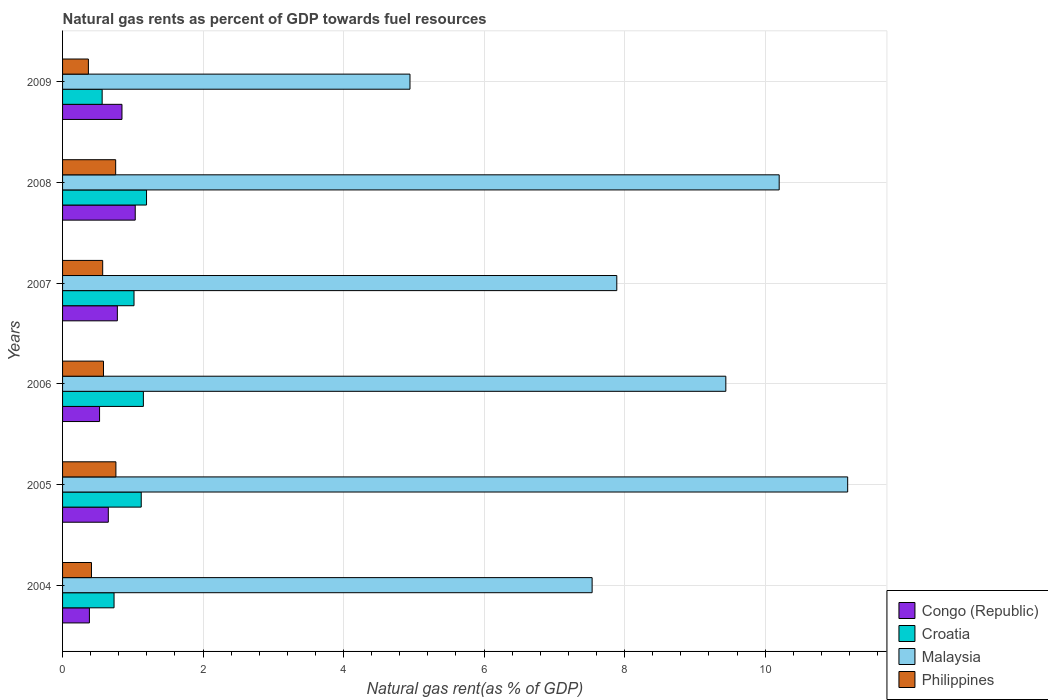How many different coloured bars are there?
Ensure brevity in your answer.  4. What is the label of the 6th group of bars from the top?
Ensure brevity in your answer.  2004. What is the natural gas rent in Croatia in 2009?
Offer a terse response. 0.56. Across all years, what is the maximum natural gas rent in Philippines?
Make the answer very short. 0.76. Across all years, what is the minimum natural gas rent in Philippines?
Your response must be concise. 0.37. In which year was the natural gas rent in Malaysia maximum?
Your answer should be compact. 2005. What is the total natural gas rent in Philippines in the graph?
Your answer should be compact. 3.45. What is the difference between the natural gas rent in Croatia in 2004 and that in 2009?
Your answer should be compact. 0.17. What is the difference between the natural gas rent in Philippines in 2005 and the natural gas rent in Congo (Republic) in 2008?
Ensure brevity in your answer.  -0.28. What is the average natural gas rent in Malaysia per year?
Your response must be concise. 8.53. In the year 2007, what is the difference between the natural gas rent in Malaysia and natural gas rent in Philippines?
Make the answer very short. 7.32. In how many years, is the natural gas rent in Philippines greater than 2.4 %?
Make the answer very short. 0. What is the ratio of the natural gas rent in Malaysia in 2005 to that in 2008?
Provide a short and direct response. 1.1. Is the difference between the natural gas rent in Malaysia in 2004 and 2008 greater than the difference between the natural gas rent in Philippines in 2004 and 2008?
Your response must be concise. No. What is the difference between the highest and the second highest natural gas rent in Malaysia?
Offer a terse response. 0.97. What is the difference between the highest and the lowest natural gas rent in Croatia?
Keep it short and to the point. 0.63. In how many years, is the natural gas rent in Malaysia greater than the average natural gas rent in Malaysia taken over all years?
Your response must be concise. 3. Is the sum of the natural gas rent in Malaysia in 2005 and 2006 greater than the maximum natural gas rent in Philippines across all years?
Make the answer very short. Yes. What does the 2nd bar from the top in 2004 represents?
Provide a succinct answer. Malaysia. What does the 3rd bar from the bottom in 2005 represents?
Offer a very short reply. Malaysia. How many years are there in the graph?
Provide a short and direct response. 6. Are the values on the major ticks of X-axis written in scientific E-notation?
Make the answer very short. No. Does the graph contain any zero values?
Provide a short and direct response. No. What is the title of the graph?
Make the answer very short. Natural gas rents as percent of GDP towards fuel resources. Does "Eritrea" appear as one of the legend labels in the graph?
Provide a succinct answer. No. What is the label or title of the X-axis?
Provide a succinct answer. Natural gas rent(as % of GDP). What is the Natural gas rent(as % of GDP) of Congo (Republic) in 2004?
Ensure brevity in your answer.  0.38. What is the Natural gas rent(as % of GDP) of Croatia in 2004?
Your answer should be compact. 0.73. What is the Natural gas rent(as % of GDP) of Malaysia in 2004?
Your response must be concise. 7.54. What is the Natural gas rent(as % of GDP) of Philippines in 2004?
Keep it short and to the point. 0.41. What is the Natural gas rent(as % of GDP) of Congo (Republic) in 2005?
Your response must be concise. 0.65. What is the Natural gas rent(as % of GDP) of Croatia in 2005?
Provide a succinct answer. 1.12. What is the Natural gas rent(as % of GDP) in Malaysia in 2005?
Provide a succinct answer. 11.18. What is the Natural gas rent(as % of GDP) in Philippines in 2005?
Make the answer very short. 0.76. What is the Natural gas rent(as % of GDP) of Congo (Republic) in 2006?
Offer a very short reply. 0.53. What is the Natural gas rent(as % of GDP) in Croatia in 2006?
Your answer should be very brief. 1.15. What is the Natural gas rent(as % of GDP) of Malaysia in 2006?
Make the answer very short. 9.44. What is the Natural gas rent(as % of GDP) of Philippines in 2006?
Provide a succinct answer. 0.58. What is the Natural gas rent(as % of GDP) of Congo (Republic) in 2007?
Give a very brief answer. 0.78. What is the Natural gas rent(as % of GDP) of Croatia in 2007?
Provide a short and direct response. 1.02. What is the Natural gas rent(as % of GDP) of Malaysia in 2007?
Your answer should be very brief. 7.89. What is the Natural gas rent(as % of GDP) of Philippines in 2007?
Make the answer very short. 0.57. What is the Natural gas rent(as % of GDP) in Congo (Republic) in 2008?
Your answer should be very brief. 1.03. What is the Natural gas rent(as % of GDP) in Croatia in 2008?
Keep it short and to the point. 1.2. What is the Natural gas rent(as % of GDP) of Malaysia in 2008?
Give a very brief answer. 10.2. What is the Natural gas rent(as % of GDP) in Philippines in 2008?
Your answer should be very brief. 0.76. What is the Natural gas rent(as % of GDP) in Congo (Republic) in 2009?
Your answer should be very brief. 0.85. What is the Natural gas rent(as % of GDP) in Croatia in 2009?
Ensure brevity in your answer.  0.56. What is the Natural gas rent(as % of GDP) of Malaysia in 2009?
Keep it short and to the point. 4.95. What is the Natural gas rent(as % of GDP) in Philippines in 2009?
Provide a short and direct response. 0.37. Across all years, what is the maximum Natural gas rent(as % of GDP) of Congo (Republic)?
Offer a very short reply. 1.03. Across all years, what is the maximum Natural gas rent(as % of GDP) in Croatia?
Offer a very short reply. 1.2. Across all years, what is the maximum Natural gas rent(as % of GDP) in Malaysia?
Ensure brevity in your answer.  11.18. Across all years, what is the maximum Natural gas rent(as % of GDP) of Philippines?
Offer a terse response. 0.76. Across all years, what is the minimum Natural gas rent(as % of GDP) of Congo (Republic)?
Keep it short and to the point. 0.38. Across all years, what is the minimum Natural gas rent(as % of GDP) of Croatia?
Your answer should be very brief. 0.56. Across all years, what is the minimum Natural gas rent(as % of GDP) in Malaysia?
Offer a very short reply. 4.95. Across all years, what is the minimum Natural gas rent(as % of GDP) of Philippines?
Keep it short and to the point. 0.37. What is the total Natural gas rent(as % of GDP) of Congo (Republic) in the graph?
Offer a terse response. 4.22. What is the total Natural gas rent(as % of GDP) in Croatia in the graph?
Your response must be concise. 5.78. What is the total Natural gas rent(as % of GDP) in Malaysia in the graph?
Make the answer very short. 51.19. What is the total Natural gas rent(as % of GDP) of Philippines in the graph?
Your answer should be very brief. 3.45. What is the difference between the Natural gas rent(as % of GDP) of Congo (Republic) in 2004 and that in 2005?
Offer a very short reply. -0.27. What is the difference between the Natural gas rent(as % of GDP) of Croatia in 2004 and that in 2005?
Ensure brevity in your answer.  -0.39. What is the difference between the Natural gas rent(as % of GDP) of Malaysia in 2004 and that in 2005?
Keep it short and to the point. -3.64. What is the difference between the Natural gas rent(as % of GDP) in Philippines in 2004 and that in 2005?
Provide a short and direct response. -0.35. What is the difference between the Natural gas rent(as % of GDP) in Congo (Republic) in 2004 and that in 2006?
Provide a succinct answer. -0.14. What is the difference between the Natural gas rent(as % of GDP) in Croatia in 2004 and that in 2006?
Your response must be concise. -0.42. What is the difference between the Natural gas rent(as % of GDP) of Malaysia in 2004 and that in 2006?
Provide a succinct answer. -1.9. What is the difference between the Natural gas rent(as % of GDP) of Philippines in 2004 and that in 2006?
Your answer should be very brief. -0.17. What is the difference between the Natural gas rent(as % of GDP) of Congo (Republic) in 2004 and that in 2007?
Keep it short and to the point. -0.4. What is the difference between the Natural gas rent(as % of GDP) in Croatia in 2004 and that in 2007?
Your answer should be compact. -0.28. What is the difference between the Natural gas rent(as % of GDP) of Malaysia in 2004 and that in 2007?
Provide a succinct answer. -0.35. What is the difference between the Natural gas rent(as % of GDP) of Philippines in 2004 and that in 2007?
Provide a short and direct response. -0.16. What is the difference between the Natural gas rent(as % of GDP) in Congo (Republic) in 2004 and that in 2008?
Keep it short and to the point. -0.65. What is the difference between the Natural gas rent(as % of GDP) of Croatia in 2004 and that in 2008?
Keep it short and to the point. -0.46. What is the difference between the Natural gas rent(as % of GDP) in Malaysia in 2004 and that in 2008?
Make the answer very short. -2.66. What is the difference between the Natural gas rent(as % of GDP) of Philippines in 2004 and that in 2008?
Provide a short and direct response. -0.34. What is the difference between the Natural gas rent(as % of GDP) of Congo (Republic) in 2004 and that in 2009?
Your answer should be compact. -0.46. What is the difference between the Natural gas rent(as % of GDP) of Croatia in 2004 and that in 2009?
Give a very brief answer. 0.17. What is the difference between the Natural gas rent(as % of GDP) in Malaysia in 2004 and that in 2009?
Provide a short and direct response. 2.59. What is the difference between the Natural gas rent(as % of GDP) of Philippines in 2004 and that in 2009?
Offer a terse response. 0.04. What is the difference between the Natural gas rent(as % of GDP) in Congo (Republic) in 2005 and that in 2006?
Ensure brevity in your answer.  0.12. What is the difference between the Natural gas rent(as % of GDP) in Croatia in 2005 and that in 2006?
Offer a very short reply. -0.03. What is the difference between the Natural gas rent(as % of GDP) of Malaysia in 2005 and that in 2006?
Offer a very short reply. 1.73. What is the difference between the Natural gas rent(as % of GDP) in Philippines in 2005 and that in 2006?
Make the answer very short. 0.18. What is the difference between the Natural gas rent(as % of GDP) of Congo (Republic) in 2005 and that in 2007?
Give a very brief answer. -0.13. What is the difference between the Natural gas rent(as % of GDP) of Croatia in 2005 and that in 2007?
Keep it short and to the point. 0.1. What is the difference between the Natural gas rent(as % of GDP) in Malaysia in 2005 and that in 2007?
Keep it short and to the point. 3.29. What is the difference between the Natural gas rent(as % of GDP) of Philippines in 2005 and that in 2007?
Make the answer very short. 0.19. What is the difference between the Natural gas rent(as % of GDP) in Congo (Republic) in 2005 and that in 2008?
Give a very brief answer. -0.38. What is the difference between the Natural gas rent(as % of GDP) of Croatia in 2005 and that in 2008?
Your answer should be very brief. -0.08. What is the difference between the Natural gas rent(as % of GDP) of Malaysia in 2005 and that in 2008?
Make the answer very short. 0.97. What is the difference between the Natural gas rent(as % of GDP) of Philippines in 2005 and that in 2008?
Make the answer very short. 0. What is the difference between the Natural gas rent(as % of GDP) in Congo (Republic) in 2005 and that in 2009?
Offer a very short reply. -0.19. What is the difference between the Natural gas rent(as % of GDP) in Croatia in 2005 and that in 2009?
Your response must be concise. 0.56. What is the difference between the Natural gas rent(as % of GDP) in Malaysia in 2005 and that in 2009?
Provide a succinct answer. 6.23. What is the difference between the Natural gas rent(as % of GDP) in Philippines in 2005 and that in 2009?
Your response must be concise. 0.39. What is the difference between the Natural gas rent(as % of GDP) of Congo (Republic) in 2006 and that in 2007?
Your answer should be very brief. -0.25. What is the difference between the Natural gas rent(as % of GDP) in Croatia in 2006 and that in 2007?
Provide a succinct answer. 0.13. What is the difference between the Natural gas rent(as % of GDP) in Malaysia in 2006 and that in 2007?
Make the answer very short. 1.55. What is the difference between the Natural gas rent(as % of GDP) of Philippines in 2006 and that in 2007?
Provide a succinct answer. 0.01. What is the difference between the Natural gas rent(as % of GDP) of Congo (Republic) in 2006 and that in 2008?
Offer a very short reply. -0.51. What is the difference between the Natural gas rent(as % of GDP) of Croatia in 2006 and that in 2008?
Keep it short and to the point. -0.04. What is the difference between the Natural gas rent(as % of GDP) of Malaysia in 2006 and that in 2008?
Provide a short and direct response. -0.76. What is the difference between the Natural gas rent(as % of GDP) in Philippines in 2006 and that in 2008?
Make the answer very short. -0.17. What is the difference between the Natural gas rent(as % of GDP) of Congo (Republic) in 2006 and that in 2009?
Offer a terse response. -0.32. What is the difference between the Natural gas rent(as % of GDP) of Croatia in 2006 and that in 2009?
Your answer should be compact. 0.59. What is the difference between the Natural gas rent(as % of GDP) in Malaysia in 2006 and that in 2009?
Your answer should be very brief. 4.5. What is the difference between the Natural gas rent(as % of GDP) of Philippines in 2006 and that in 2009?
Offer a very short reply. 0.21. What is the difference between the Natural gas rent(as % of GDP) of Congo (Republic) in 2007 and that in 2008?
Provide a short and direct response. -0.25. What is the difference between the Natural gas rent(as % of GDP) of Croatia in 2007 and that in 2008?
Your answer should be compact. -0.18. What is the difference between the Natural gas rent(as % of GDP) in Malaysia in 2007 and that in 2008?
Give a very brief answer. -2.31. What is the difference between the Natural gas rent(as % of GDP) in Philippines in 2007 and that in 2008?
Provide a short and direct response. -0.18. What is the difference between the Natural gas rent(as % of GDP) of Congo (Republic) in 2007 and that in 2009?
Your answer should be compact. -0.07. What is the difference between the Natural gas rent(as % of GDP) in Croatia in 2007 and that in 2009?
Your answer should be very brief. 0.45. What is the difference between the Natural gas rent(as % of GDP) of Malaysia in 2007 and that in 2009?
Provide a short and direct response. 2.94. What is the difference between the Natural gas rent(as % of GDP) of Philippines in 2007 and that in 2009?
Your answer should be very brief. 0.2. What is the difference between the Natural gas rent(as % of GDP) in Congo (Republic) in 2008 and that in 2009?
Offer a terse response. 0.19. What is the difference between the Natural gas rent(as % of GDP) in Croatia in 2008 and that in 2009?
Provide a succinct answer. 0.63. What is the difference between the Natural gas rent(as % of GDP) of Malaysia in 2008 and that in 2009?
Ensure brevity in your answer.  5.26. What is the difference between the Natural gas rent(as % of GDP) of Philippines in 2008 and that in 2009?
Provide a succinct answer. 0.39. What is the difference between the Natural gas rent(as % of GDP) of Congo (Republic) in 2004 and the Natural gas rent(as % of GDP) of Croatia in 2005?
Your answer should be very brief. -0.74. What is the difference between the Natural gas rent(as % of GDP) in Congo (Republic) in 2004 and the Natural gas rent(as % of GDP) in Malaysia in 2005?
Your answer should be very brief. -10.79. What is the difference between the Natural gas rent(as % of GDP) of Congo (Republic) in 2004 and the Natural gas rent(as % of GDP) of Philippines in 2005?
Make the answer very short. -0.38. What is the difference between the Natural gas rent(as % of GDP) of Croatia in 2004 and the Natural gas rent(as % of GDP) of Malaysia in 2005?
Offer a very short reply. -10.44. What is the difference between the Natural gas rent(as % of GDP) of Croatia in 2004 and the Natural gas rent(as % of GDP) of Philippines in 2005?
Your response must be concise. -0.03. What is the difference between the Natural gas rent(as % of GDP) of Malaysia in 2004 and the Natural gas rent(as % of GDP) of Philippines in 2005?
Your response must be concise. 6.78. What is the difference between the Natural gas rent(as % of GDP) of Congo (Republic) in 2004 and the Natural gas rent(as % of GDP) of Croatia in 2006?
Offer a terse response. -0.77. What is the difference between the Natural gas rent(as % of GDP) in Congo (Republic) in 2004 and the Natural gas rent(as % of GDP) in Malaysia in 2006?
Keep it short and to the point. -9.06. What is the difference between the Natural gas rent(as % of GDP) of Congo (Republic) in 2004 and the Natural gas rent(as % of GDP) of Philippines in 2006?
Ensure brevity in your answer.  -0.2. What is the difference between the Natural gas rent(as % of GDP) in Croatia in 2004 and the Natural gas rent(as % of GDP) in Malaysia in 2006?
Provide a short and direct response. -8.71. What is the difference between the Natural gas rent(as % of GDP) in Croatia in 2004 and the Natural gas rent(as % of GDP) in Philippines in 2006?
Keep it short and to the point. 0.15. What is the difference between the Natural gas rent(as % of GDP) in Malaysia in 2004 and the Natural gas rent(as % of GDP) in Philippines in 2006?
Ensure brevity in your answer.  6.96. What is the difference between the Natural gas rent(as % of GDP) in Congo (Republic) in 2004 and the Natural gas rent(as % of GDP) in Croatia in 2007?
Your answer should be very brief. -0.64. What is the difference between the Natural gas rent(as % of GDP) of Congo (Republic) in 2004 and the Natural gas rent(as % of GDP) of Malaysia in 2007?
Give a very brief answer. -7.51. What is the difference between the Natural gas rent(as % of GDP) of Congo (Republic) in 2004 and the Natural gas rent(as % of GDP) of Philippines in 2007?
Keep it short and to the point. -0.19. What is the difference between the Natural gas rent(as % of GDP) in Croatia in 2004 and the Natural gas rent(as % of GDP) in Malaysia in 2007?
Your answer should be compact. -7.16. What is the difference between the Natural gas rent(as % of GDP) in Croatia in 2004 and the Natural gas rent(as % of GDP) in Philippines in 2007?
Make the answer very short. 0.16. What is the difference between the Natural gas rent(as % of GDP) of Malaysia in 2004 and the Natural gas rent(as % of GDP) of Philippines in 2007?
Ensure brevity in your answer.  6.97. What is the difference between the Natural gas rent(as % of GDP) of Congo (Republic) in 2004 and the Natural gas rent(as % of GDP) of Croatia in 2008?
Your answer should be very brief. -0.81. What is the difference between the Natural gas rent(as % of GDP) in Congo (Republic) in 2004 and the Natural gas rent(as % of GDP) in Malaysia in 2008?
Make the answer very short. -9.82. What is the difference between the Natural gas rent(as % of GDP) of Congo (Republic) in 2004 and the Natural gas rent(as % of GDP) of Philippines in 2008?
Ensure brevity in your answer.  -0.37. What is the difference between the Natural gas rent(as % of GDP) in Croatia in 2004 and the Natural gas rent(as % of GDP) in Malaysia in 2008?
Provide a short and direct response. -9.47. What is the difference between the Natural gas rent(as % of GDP) in Croatia in 2004 and the Natural gas rent(as % of GDP) in Philippines in 2008?
Ensure brevity in your answer.  -0.02. What is the difference between the Natural gas rent(as % of GDP) in Malaysia in 2004 and the Natural gas rent(as % of GDP) in Philippines in 2008?
Provide a short and direct response. 6.78. What is the difference between the Natural gas rent(as % of GDP) in Congo (Republic) in 2004 and the Natural gas rent(as % of GDP) in Croatia in 2009?
Make the answer very short. -0.18. What is the difference between the Natural gas rent(as % of GDP) of Congo (Republic) in 2004 and the Natural gas rent(as % of GDP) of Malaysia in 2009?
Keep it short and to the point. -4.56. What is the difference between the Natural gas rent(as % of GDP) of Congo (Republic) in 2004 and the Natural gas rent(as % of GDP) of Philippines in 2009?
Ensure brevity in your answer.  0.01. What is the difference between the Natural gas rent(as % of GDP) in Croatia in 2004 and the Natural gas rent(as % of GDP) in Malaysia in 2009?
Make the answer very short. -4.21. What is the difference between the Natural gas rent(as % of GDP) in Croatia in 2004 and the Natural gas rent(as % of GDP) in Philippines in 2009?
Your answer should be compact. 0.37. What is the difference between the Natural gas rent(as % of GDP) in Malaysia in 2004 and the Natural gas rent(as % of GDP) in Philippines in 2009?
Keep it short and to the point. 7.17. What is the difference between the Natural gas rent(as % of GDP) of Congo (Republic) in 2005 and the Natural gas rent(as % of GDP) of Croatia in 2006?
Make the answer very short. -0.5. What is the difference between the Natural gas rent(as % of GDP) in Congo (Republic) in 2005 and the Natural gas rent(as % of GDP) in Malaysia in 2006?
Your answer should be compact. -8.79. What is the difference between the Natural gas rent(as % of GDP) in Congo (Republic) in 2005 and the Natural gas rent(as % of GDP) in Philippines in 2006?
Provide a short and direct response. 0.07. What is the difference between the Natural gas rent(as % of GDP) in Croatia in 2005 and the Natural gas rent(as % of GDP) in Malaysia in 2006?
Ensure brevity in your answer.  -8.32. What is the difference between the Natural gas rent(as % of GDP) of Croatia in 2005 and the Natural gas rent(as % of GDP) of Philippines in 2006?
Provide a short and direct response. 0.54. What is the difference between the Natural gas rent(as % of GDP) of Malaysia in 2005 and the Natural gas rent(as % of GDP) of Philippines in 2006?
Make the answer very short. 10.59. What is the difference between the Natural gas rent(as % of GDP) of Congo (Republic) in 2005 and the Natural gas rent(as % of GDP) of Croatia in 2007?
Keep it short and to the point. -0.37. What is the difference between the Natural gas rent(as % of GDP) of Congo (Republic) in 2005 and the Natural gas rent(as % of GDP) of Malaysia in 2007?
Offer a very short reply. -7.24. What is the difference between the Natural gas rent(as % of GDP) of Congo (Republic) in 2005 and the Natural gas rent(as % of GDP) of Philippines in 2007?
Your answer should be compact. 0.08. What is the difference between the Natural gas rent(as % of GDP) in Croatia in 2005 and the Natural gas rent(as % of GDP) in Malaysia in 2007?
Give a very brief answer. -6.77. What is the difference between the Natural gas rent(as % of GDP) of Croatia in 2005 and the Natural gas rent(as % of GDP) of Philippines in 2007?
Provide a succinct answer. 0.55. What is the difference between the Natural gas rent(as % of GDP) in Malaysia in 2005 and the Natural gas rent(as % of GDP) in Philippines in 2007?
Offer a terse response. 10.6. What is the difference between the Natural gas rent(as % of GDP) in Congo (Republic) in 2005 and the Natural gas rent(as % of GDP) in Croatia in 2008?
Ensure brevity in your answer.  -0.54. What is the difference between the Natural gas rent(as % of GDP) of Congo (Republic) in 2005 and the Natural gas rent(as % of GDP) of Malaysia in 2008?
Give a very brief answer. -9.55. What is the difference between the Natural gas rent(as % of GDP) of Congo (Republic) in 2005 and the Natural gas rent(as % of GDP) of Philippines in 2008?
Provide a short and direct response. -0.1. What is the difference between the Natural gas rent(as % of GDP) in Croatia in 2005 and the Natural gas rent(as % of GDP) in Malaysia in 2008?
Your response must be concise. -9.08. What is the difference between the Natural gas rent(as % of GDP) in Croatia in 2005 and the Natural gas rent(as % of GDP) in Philippines in 2008?
Provide a short and direct response. 0.36. What is the difference between the Natural gas rent(as % of GDP) of Malaysia in 2005 and the Natural gas rent(as % of GDP) of Philippines in 2008?
Provide a short and direct response. 10.42. What is the difference between the Natural gas rent(as % of GDP) of Congo (Republic) in 2005 and the Natural gas rent(as % of GDP) of Croatia in 2009?
Your response must be concise. 0.09. What is the difference between the Natural gas rent(as % of GDP) of Congo (Republic) in 2005 and the Natural gas rent(as % of GDP) of Malaysia in 2009?
Your answer should be compact. -4.29. What is the difference between the Natural gas rent(as % of GDP) of Congo (Republic) in 2005 and the Natural gas rent(as % of GDP) of Philippines in 2009?
Give a very brief answer. 0.28. What is the difference between the Natural gas rent(as % of GDP) of Croatia in 2005 and the Natural gas rent(as % of GDP) of Malaysia in 2009?
Give a very brief answer. -3.83. What is the difference between the Natural gas rent(as % of GDP) in Croatia in 2005 and the Natural gas rent(as % of GDP) in Philippines in 2009?
Give a very brief answer. 0.75. What is the difference between the Natural gas rent(as % of GDP) of Malaysia in 2005 and the Natural gas rent(as % of GDP) of Philippines in 2009?
Make the answer very short. 10.81. What is the difference between the Natural gas rent(as % of GDP) of Congo (Republic) in 2006 and the Natural gas rent(as % of GDP) of Croatia in 2007?
Give a very brief answer. -0.49. What is the difference between the Natural gas rent(as % of GDP) of Congo (Republic) in 2006 and the Natural gas rent(as % of GDP) of Malaysia in 2007?
Provide a short and direct response. -7.36. What is the difference between the Natural gas rent(as % of GDP) of Congo (Republic) in 2006 and the Natural gas rent(as % of GDP) of Philippines in 2007?
Make the answer very short. -0.04. What is the difference between the Natural gas rent(as % of GDP) of Croatia in 2006 and the Natural gas rent(as % of GDP) of Malaysia in 2007?
Offer a terse response. -6.74. What is the difference between the Natural gas rent(as % of GDP) in Croatia in 2006 and the Natural gas rent(as % of GDP) in Philippines in 2007?
Keep it short and to the point. 0.58. What is the difference between the Natural gas rent(as % of GDP) in Malaysia in 2006 and the Natural gas rent(as % of GDP) in Philippines in 2007?
Provide a succinct answer. 8.87. What is the difference between the Natural gas rent(as % of GDP) of Congo (Republic) in 2006 and the Natural gas rent(as % of GDP) of Croatia in 2008?
Offer a very short reply. -0.67. What is the difference between the Natural gas rent(as % of GDP) of Congo (Republic) in 2006 and the Natural gas rent(as % of GDP) of Malaysia in 2008?
Provide a succinct answer. -9.67. What is the difference between the Natural gas rent(as % of GDP) of Congo (Republic) in 2006 and the Natural gas rent(as % of GDP) of Philippines in 2008?
Your response must be concise. -0.23. What is the difference between the Natural gas rent(as % of GDP) of Croatia in 2006 and the Natural gas rent(as % of GDP) of Malaysia in 2008?
Your answer should be compact. -9.05. What is the difference between the Natural gas rent(as % of GDP) in Croatia in 2006 and the Natural gas rent(as % of GDP) in Philippines in 2008?
Your answer should be very brief. 0.39. What is the difference between the Natural gas rent(as % of GDP) in Malaysia in 2006 and the Natural gas rent(as % of GDP) in Philippines in 2008?
Your answer should be compact. 8.69. What is the difference between the Natural gas rent(as % of GDP) in Congo (Republic) in 2006 and the Natural gas rent(as % of GDP) in Croatia in 2009?
Your answer should be very brief. -0.04. What is the difference between the Natural gas rent(as % of GDP) of Congo (Republic) in 2006 and the Natural gas rent(as % of GDP) of Malaysia in 2009?
Keep it short and to the point. -4.42. What is the difference between the Natural gas rent(as % of GDP) of Congo (Republic) in 2006 and the Natural gas rent(as % of GDP) of Philippines in 2009?
Provide a succinct answer. 0.16. What is the difference between the Natural gas rent(as % of GDP) of Croatia in 2006 and the Natural gas rent(as % of GDP) of Malaysia in 2009?
Provide a succinct answer. -3.79. What is the difference between the Natural gas rent(as % of GDP) of Croatia in 2006 and the Natural gas rent(as % of GDP) of Philippines in 2009?
Offer a terse response. 0.78. What is the difference between the Natural gas rent(as % of GDP) in Malaysia in 2006 and the Natural gas rent(as % of GDP) in Philippines in 2009?
Your answer should be compact. 9.07. What is the difference between the Natural gas rent(as % of GDP) of Congo (Republic) in 2007 and the Natural gas rent(as % of GDP) of Croatia in 2008?
Give a very brief answer. -0.42. What is the difference between the Natural gas rent(as % of GDP) of Congo (Republic) in 2007 and the Natural gas rent(as % of GDP) of Malaysia in 2008?
Offer a very short reply. -9.42. What is the difference between the Natural gas rent(as % of GDP) of Congo (Republic) in 2007 and the Natural gas rent(as % of GDP) of Philippines in 2008?
Your answer should be compact. 0.02. What is the difference between the Natural gas rent(as % of GDP) of Croatia in 2007 and the Natural gas rent(as % of GDP) of Malaysia in 2008?
Ensure brevity in your answer.  -9.18. What is the difference between the Natural gas rent(as % of GDP) of Croatia in 2007 and the Natural gas rent(as % of GDP) of Philippines in 2008?
Give a very brief answer. 0.26. What is the difference between the Natural gas rent(as % of GDP) in Malaysia in 2007 and the Natural gas rent(as % of GDP) in Philippines in 2008?
Provide a short and direct response. 7.13. What is the difference between the Natural gas rent(as % of GDP) in Congo (Republic) in 2007 and the Natural gas rent(as % of GDP) in Croatia in 2009?
Provide a succinct answer. 0.22. What is the difference between the Natural gas rent(as % of GDP) in Congo (Republic) in 2007 and the Natural gas rent(as % of GDP) in Malaysia in 2009?
Your answer should be very brief. -4.17. What is the difference between the Natural gas rent(as % of GDP) of Congo (Republic) in 2007 and the Natural gas rent(as % of GDP) of Philippines in 2009?
Your answer should be very brief. 0.41. What is the difference between the Natural gas rent(as % of GDP) in Croatia in 2007 and the Natural gas rent(as % of GDP) in Malaysia in 2009?
Offer a terse response. -3.93. What is the difference between the Natural gas rent(as % of GDP) of Croatia in 2007 and the Natural gas rent(as % of GDP) of Philippines in 2009?
Provide a short and direct response. 0.65. What is the difference between the Natural gas rent(as % of GDP) in Malaysia in 2007 and the Natural gas rent(as % of GDP) in Philippines in 2009?
Offer a terse response. 7.52. What is the difference between the Natural gas rent(as % of GDP) in Congo (Republic) in 2008 and the Natural gas rent(as % of GDP) in Croatia in 2009?
Provide a succinct answer. 0.47. What is the difference between the Natural gas rent(as % of GDP) in Congo (Republic) in 2008 and the Natural gas rent(as % of GDP) in Malaysia in 2009?
Keep it short and to the point. -3.91. What is the difference between the Natural gas rent(as % of GDP) in Congo (Republic) in 2008 and the Natural gas rent(as % of GDP) in Philippines in 2009?
Give a very brief answer. 0.67. What is the difference between the Natural gas rent(as % of GDP) of Croatia in 2008 and the Natural gas rent(as % of GDP) of Malaysia in 2009?
Provide a short and direct response. -3.75. What is the difference between the Natural gas rent(as % of GDP) in Croatia in 2008 and the Natural gas rent(as % of GDP) in Philippines in 2009?
Make the answer very short. 0.83. What is the difference between the Natural gas rent(as % of GDP) of Malaysia in 2008 and the Natural gas rent(as % of GDP) of Philippines in 2009?
Keep it short and to the point. 9.83. What is the average Natural gas rent(as % of GDP) of Congo (Republic) per year?
Offer a very short reply. 0.7. What is the average Natural gas rent(as % of GDP) of Croatia per year?
Your answer should be very brief. 0.96. What is the average Natural gas rent(as % of GDP) of Malaysia per year?
Your answer should be very brief. 8.53. What is the average Natural gas rent(as % of GDP) in Philippines per year?
Make the answer very short. 0.57. In the year 2004, what is the difference between the Natural gas rent(as % of GDP) in Congo (Republic) and Natural gas rent(as % of GDP) in Croatia?
Provide a short and direct response. -0.35. In the year 2004, what is the difference between the Natural gas rent(as % of GDP) of Congo (Republic) and Natural gas rent(as % of GDP) of Malaysia?
Provide a short and direct response. -7.16. In the year 2004, what is the difference between the Natural gas rent(as % of GDP) in Congo (Republic) and Natural gas rent(as % of GDP) in Philippines?
Ensure brevity in your answer.  -0.03. In the year 2004, what is the difference between the Natural gas rent(as % of GDP) in Croatia and Natural gas rent(as % of GDP) in Malaysia?
Make the answer very short. -6.81. In the year 2004, what is the difference between the Natural gas rent(as % of GDP) of Croatia and Natural gas rent(as % of GDP) of Philippines?
Keep it short and to the point. 0.32. In the year 2004, what is the difference between the Natural gas rent(as % of GDP) of Malaysia and Natural gas rent(as % of GDP) of Philippines?
Make the answer very short. 7.13. In the year 2005, what is the difference between the Natural gas rent(as % of GDP) in Congo (Republic) and Natural gas rent(as % of GDP) in Croatia?
Keep it short and to the point. -0.47. In the year 2005, what is the difference between the Natural gas rent(as % of GDP) in Congo (Republic) and Natural gas rent(as % of GDP) in Malaysia?
Your response must be concise. -10.52. In the year 2005, what is the difference between the Natural gas rent(as % of GDP) of Congo (Republic) and Natural gas rent(as % of GDP) of Philippines?
Your answer should be compact. -0.11. In the year 2005, what is the difference between the Natural gas rent(as % of GDP) in Croatia and Natural gas rent(as % of GDP) in Malaysia?
Your answer should be very brief. -10.06. In the year 2005, what is the difference between the Natural gas rent(as % of GDP) in Croatia and Natural gas rent(as % of GDP) in Philippines?
Ensure brevity in your answer.  0.36. In the year 2005, what is the difference between the Natural gas rent(as % of GDP) in Malaysia and Natural gas rent(as % of GDP) in Philippines?
Provide a short and direct response. 10.42. In the year 2006, what is the difference between the Natural gas rent(as % of GDP) of Congo (Republic) and Natural gas rent(as % of GDP) of Croatia?
Offer a very short reply. -0.62. In the year 2006, what is the difference between the Natural gas rent(as % of GDP) in Congo (Republic) and Natural gas rent(as % of GDP) in Malaysia?
Provide a short and direct response. -8.91. In the year 2006, what is the difference between the Natural gas rent(as % of GDP) in Congo (Republic) and Natural gas rent(as % of GDP) in Philippines?
Provide a short and direct response. -0.06. In the year 2006, what is the difference between the Natural gas rent(as % of GDP) in Croatia and Natural gas rent(as % of GDP) in Malaysia?
Your answer should be compact. -8.29. In the year 2006, what is the difference between the Natural gas rent(as % of GDP) of Croatia and Natural gas rent(as % of GDP) of Philippines?
Give a very brief answer. 0.57. In the year 2006, what is the difference between the Natural gas rent(as % of GDP) of Malaysia and Natural gas rent(as % of GDP) of Philippines?
Ensure brevity in your answer.  8.86. In the year 2007, what is the difference between the Natural gas rent(as % of GDP) in Congo (Republic) and Natural gas rent(as % of GDP) in Croatia?
Give a very brief answer. -0.24. In the year 2007, what is the difference between the Natural gas rent(as % of GDP) in Congo (Republic) and Natural gas rent(as % of GDP) in Malaysia?
Your answer should be very brief. -7.11. In the year 2007, what is the difference between the Natural gas rent(as % of GDP) of Congo (Republic) and Natural gas rent(as % of GDP) of Philippines?
Keep it short and to the point. 0.21. In the year 2007, what is the difference between the Natural gas rent(as % of GDP) in Croatia and Natural gas rent(as % of GDP) in Malaysia?
Your answer should be very brief. -6.87. In the year 2007, what is the difference between the Natural gas rent(as % of GDP) in Croatia and Natural gas rent(as % of GDP) in Philippines?
Offer a terse response. 0.45. In the year 2007, what is the difference between the Natural gas rent(as % of GDP) of Malaysia and Natural gas rent(as % of GDP) of Philippines?
Ensure brevity in your answer.  7.32. In the year 2008, what is the difference between the Natural gas rent(as % of GDP) of Congo (Republic) and Natural gas rent(as % of GDP) of Croatia?
Your response must be concise. -0.16. In the year 2008, what is the difference between the Natural gas rent(as % of GDP) of Congo (Republic) and Natural gas rent(as % of GDP) of Malaysia?
Ensure brevity in your answer.  -9.17. In the year 2008, what is the difference between the Natural gas rent(as % of GDP) of Congo (Republic) and Natural gas rent(as % of GDP) of Philippines?
Make the answer very short. 0.28. In the year 2008, what is the difference between the Natural gas rent(as % of GDP) of Croatia and Natural gas rent(as % of GDP) of Malaysia?
Ensure brevity in your answer.  -9.01. In the year 2008, what is the difference between the Natural gas rent(as % of GDP) of Croatia and Natural gas rent(as % of GDP) of Philippines?
Provide a succinct answer. 0.44. In the year 2008, what is the difference between the Natural gas rent(as % of GDP) in Malaysia and Natural gas rent(as % of GDP) in Philippines?
Offer a very short reply. 9.44. In the year 2009, what is the difference between the Natural gas rent(as % of GDP) of Congo (Republic) and Natural gas rent(as % of GDP) of Croatia?
Offer a very short reply. 0.28. In the year 2009, what is the difference between the Natural gas rent(as % of GDP) of Congo (Republic) and Natural gas rent(as % of GDP) of Malaysia?
Make the answer very short. -4.1. In the year 2009, what is the difference between the Natural gas rent(as % of GDP) of Congo (Republic) and Natural gas rent(as % of GDP) of Philippines?
Your response must be concise. 0.48. In the year 2009, what is the difference between the Natural gas rent(as % of GDP) in Croatia and Natural gas rent(as % of GDP) in Malaysia?
Make the answer very short. -4.38. In the year 2009, what is the difference between the Natural gas rent(as % of GDP) in Croatia and Natural gas rent(as % of GDP) in Philippines?
Offer a very short reply. 0.2. In the year 2009, what is the difference between the Natural gas rent(as % of GDP) of Malaysia and Natural gas rent(as % of GDP) of Philippines?
Your answer should be very brief. 4.58. What is the ratio of the Natural gas rent(as % of GDP) in Congo (Republic) in 2004 to that in 2005?
Your answer should be very brief. 0.59. What is the ratio of the Natural gas rent(as % of GDP) in Croatia in 2004 to that in 2005?
Your answer should be very brief. 0.65. What is the ratio of the Natural gas rent(as % of GDP) of Malaysia in 2004 to that in 2005?
Offer a very short reply. 0.67. What is the ratio of the Natural gas rent(as % of GDP) in Philippines in 2004 to that in 2005?
Your answer should be very brief. 0.54. What is the ratio of the Natural gas rent(as % of GDP) of Congo (Republic) in 2004 to that in 2006?
Provide a succinct answer. 0.73. What is the ratio of the Natural gas rent(as % of GDP) of Croatia in 2004 to that in 2006?
Offer a terse response. 0.64. What is the ratio of the Natural gas rent(as % of GDP) in Malaysia in 2004 to that in 2006?
Make the answer very short. 0.8. What is the ratio of the Natural gas rent(as % of GDP) of Philippines in 2004 to that in 2006?
Make the answer very short. 0.71. What is the ratio of the Natural gas rent(as % of GDP) of Congo (Republic) in 2004 to that in 2007?
Your answer should be compact. 0.49. What is the ratio of the Natural gas rent(as % of GDP) in Croatia in 2004 to that in 2007?
Provide a succinct answer. 0.72. What is the ratio of the Natural gas rent(as % of GDP) in Malaysia in 2004 to that in 2007?
Offer a very short reply. 0.96. What is the ratio of the Natural gas rent(as % of GDP) of Philippines in 2004 to that in 2007?
Offer a terse response. 0.72. What is the ratio of the Natural gas rent(as % of GDP) of Congo (Republic) in 2004 to that in 2008?
Provide a succinct answer. 0.37. What is the ratio of the Natural gas rent(as % of GDP) in Croatia in 2004 to that in 2008?
Give a very brief answer. 0.61. What is the ratio of the Natural gas rent(as % of GDP) of Malaysia in 2004 to that in 2008?
Your response must be concise. 0.74. What is the ratio of the Natural gas rent(as % of GDP) in Philippines in 2004 to that in 2008?
Your response must be concise. 0.54. What is the ratio of the Natural gas rent(as % of GDP) of Congo (Republic) in 2004 to that in 2009?
Keep it short and to the point. 0.45. What is the ratio of the Natural gas rent(as % of GDP) of Croatia in 2004 to that in 2009?
Give a very brief answer. 1.3. What is the ratio of the Natural gas rent(as % of GDP) of Malaysia in 2004 to that in 2009?
Make the answer very short. 1.52. What is the ratio of the Natural gas rent(as % of GDP) of Philippines in 2004 to that in 2009?
Make the answer very short. 1.12. What is the ratio of the Natural gas rent(as % of GDP) in Congo (Republic) in 2005 to that in 2006?
Your response must be concise. 1.24. What is the ratio of the Natural gas rent(as % of GDP) of Croatia in 2005 to that in 2006?
Your answer should be very brief. 0.97. What is the ratio of the Natural gas rent(as % of GDP) in Malaysia in 2005 to that in 2006?
Ensure brevity in your answer.  1.18. What is the ratio of the Natural gas rent(as % of GDP) in Philippines in 2005 to that in 2006?
Ensure brevity in your answer.  1.3. What is the ratio of the Natural gas rent(as % of GDP) of Congo (Republic) in 2005 to that in 2007?
Give a very brief answer. 0.83. What is the ratio of the Natural gas rent(as % of GDP) of Croatia in 2005 to that in 2007?
Offer a very short reply. 1.1. What is the ratio of the Natural gas rent(as % of GDP) of Malaysia in 2005 to that in 2007?
Your answer should be very brief. 1.42. What is the ratio of the Natural gas rent(as % of GDP) in Philippines in 2005 to that in 2007?
Offer a terse response. 1.33. What is the ratio of the Natural gas rent(as % of GDP) in Congo (Republic) in 2005 to that in 2008?
Offer a terse response. 0.63. What is the ratio of the Natural gas rent(as % of GDP) of Croatia in 2005 to that in 2008?
Your answer should be very brief. 0.94. What is the ratio of the Natural gas rent(as % of GDP) of Malaysia in 2005 to that in 2008?
Your answer should be very brief. 1.1. What is the ratio of the Natural gas rent(as % of GDP) in Congo (Republic) in 2005 to that in 2009?
Ensure brevity in your answer.  0.77. What is the ratio of the Natural gas rent(as % of GDP) of Croatia in 2005 to that in 2009?
Provide a short and direct response. 1.99. What is the ratio of the Natural gas rent(as % of GDP) in Malaysia in 2005 to that in 2009?
Your answer should be very brief. 2.26. What is the ratio of the Natural gas rent(as % of GDP) in Philippines in 2005 to that in 2009?
Your answer should be compact. 2.07. What is the ratio of the Natural gas rent(as % of GDP) in Congo (Republic) in 2006 to that in 2007?
Your response must be concise. 0.68. What is the ratio of the Natural gas rent(as % of GDP) in Croatia in 2006 to that in 2007?
Keep it short and to the point. 1.13. What is the ratio of the Natural gas rent(as % of GDP) in Malaysia in 2006 to that in 2007?
Your answer should be very brief. 1.2. What is the ratio of the Natural gas rent(as % of GDP) of Philippines in 2006 to that in 2007?
Provide a succinct answer. 1.02. What is the ratio of the Natural gas rent(as % of GDP) of Congo (Republic) in 2006 to that in 2008?
Offer a terse response. 0.51. What is the ratio of the Natural gas rent(as % of GDP) in Croatia in 2006 to that in 2008?
Ensure brevity in your answer.  0.96. What is the ratio of the Natural gas rent(as % of GDP) in Malaysia in 2006 to that in 2008?
Keep it short and to the point. 0.93. What is the ratio of the Natural gas rent(as % of GDP) of Philippines in 2006 to that in 2008?
Your response must be concise. 0.77. What is the ratio of the Natural gas rent(as % of GDP) in Congo (Republic) in 2006 to that in 2009?
Offer a terse response. 0.62. What is the ratio of the Natural gas rent(as % of GDP) of Croatia in 2006 to that in 2009?
Provide a short and direct response. 2.04. What is the ratio of the Natural gas rent(as % of GDP) in Malaysia in 2006 to that in 2009?
Make the answer very short. 1.91. What is the ratio of the Natural gas rent(as % of GDP) of Philippines in 2006 to that in 2009?
Offer a terse response. 1.58. What is the ratio of the Natural gas rent(as % of GDP) in Congo (Republic) in 2007 to that in 2008?
Ensure brevity in your answer.  0.75. What is the ratio of the Natural gas rent(as % of GDP) of Croatia in 2007 to that in 2008?
Provide a succinct answer. 0.85. What is the ratio of the Natural gas rent(as % of GDP) of Malaysia in 2007 to that in 2008?
Provide a short and direct response. 0.77. What is the ratio of the Natural gas rent(as % of GDP) in Philippines in 2007 to that in 2008?
Ensure brevity in your answer.  0.76. What is the ratio of the Natural gas rent(as % of GDP) of Congo (Republic) in 2007 to that in 2009?
Your answer should be very brief. 0.92. What is the ratio of the Natural gas rent(as % of GDP) of Croatia in 2007 to that in 2009?
Your answer should be compact. 1.8. What is the ratio of the Natural gas rent(as % of GDP) in Malaysia in 2007 to that in 2009?
Provide a succinct answer. 1.6. What is the ratio of the Natural gas rent(as % of GDP) of Philippines in 2007 to that in 2009?
Ensure brevity in your answer.  1.55. What is the ratio of the Natural gas rent(as % of GDP) in Congo (Republic) in 2008 to that in 2009?
Your answer should be compact. 1.22. What is the ratio of the Natural gas rent(as % of GDP) of Croatia in 2008 to that in 2009?
Your response must be concise. 2.12. What is the ratio of the Natural gas rent(as % of GDP) in Malaysia in 2008 to that in 2009?
Ensure brevity in your answer.  2.06. What is the ratio of the Natural gas rent(as % of GDP) in Philippines in 2008 to that in 2009?
Offer a very short reply. 2.06. What is the difference between the highest and the second highest Natural gas rent(as % of GDP) of Congo (Republic)?
Your response must be concise. 0.19. What is the difference between the highest and the second highest Natural gas rent(as % of GDP) of Croatia?
Give a very brief answer. 0.04. What is the difference between the highest and the second highest Natural gas rent(as % of GDP) in Malaysia?
Offer a terse response. 0.97. What is the difference between the highest and the second highest Natural gas rent(as % of GDP) of Philippines?
Give a very brief answer. 0. What is the difference between the highest and the lowest Natural gas rent(as % of GDP) of Congo (Republic)?
Your answer should be very brief. 0.65. What is the difference between the highest and the lowest Natural gas rent(as % of GDP) of Croatia?
Provide a succinct answer. 0.63. What is the difference between the highest and the lowest Natural gas rent(as % of GDP) of Malaysia?
Your answer should be very brief. 6.23. What is the difference between the highest and the lowest Natural gas rent(as % of GDP) of Philippines?
Ensure brevity in your answer.  0.39. 